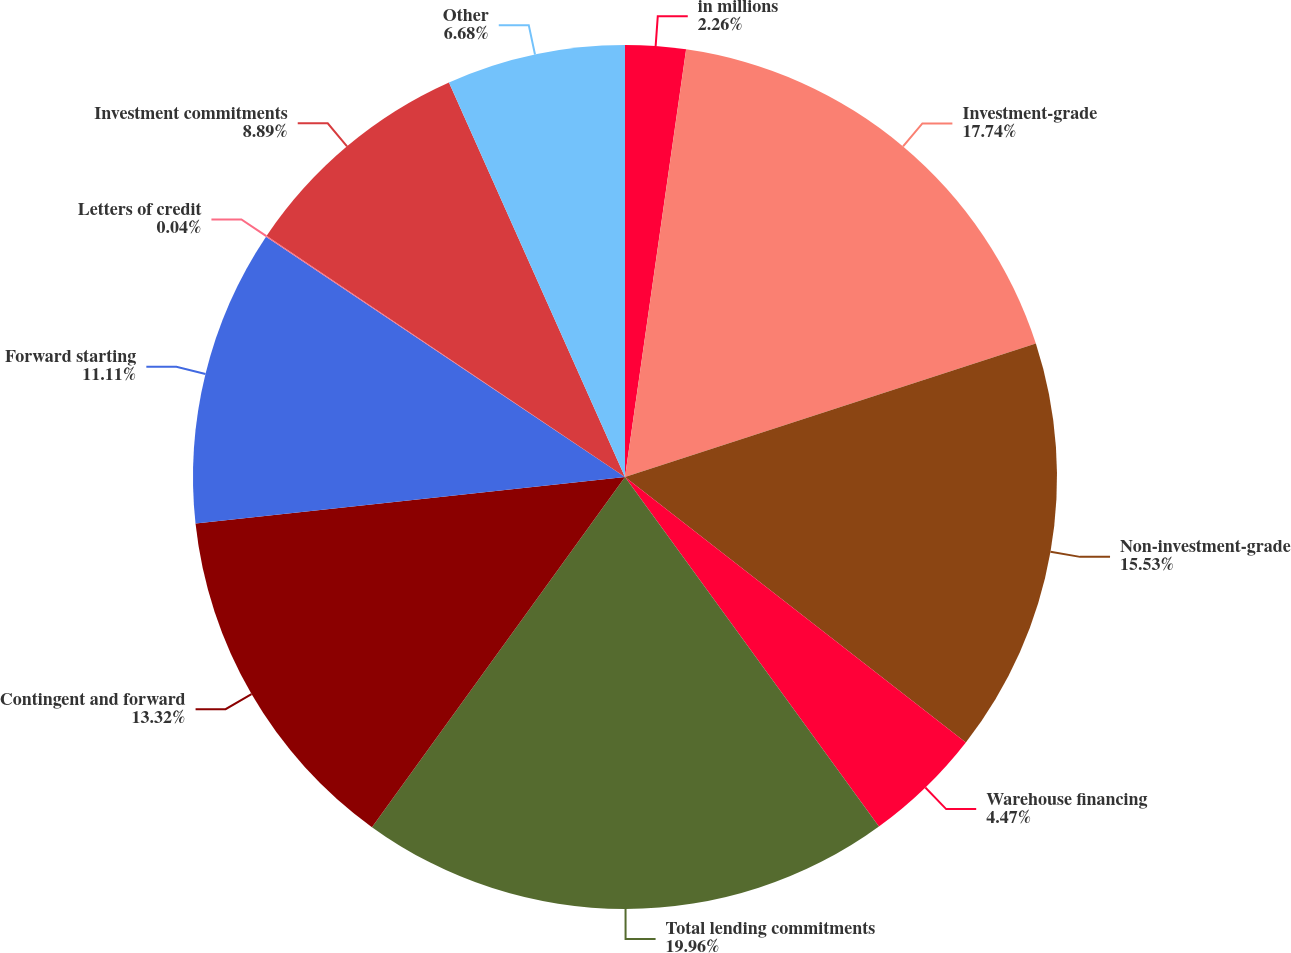<chart> <loc_0><loc_0><loc_500><loc_500><pie_chart><fcel>in millions<fcel>Investment-grade<fcel>Non-investment-grade<fcel>Warehouse financing<fcel>Total lending commitments<fcel>Contingent and forward<fcel>Forward starting<fcel>Letters of credit<fcel>Investment commitments<fcel>Other<nl><fcel>2.26%<fcel>17.74%<fcel>15.53%<fcel>4.47%<fcel>19.96%<fcel>13.32%<fcel>11.11%<fcel>0.04%<fcel>8.89%<fcel>6.68%<nl></chart> 